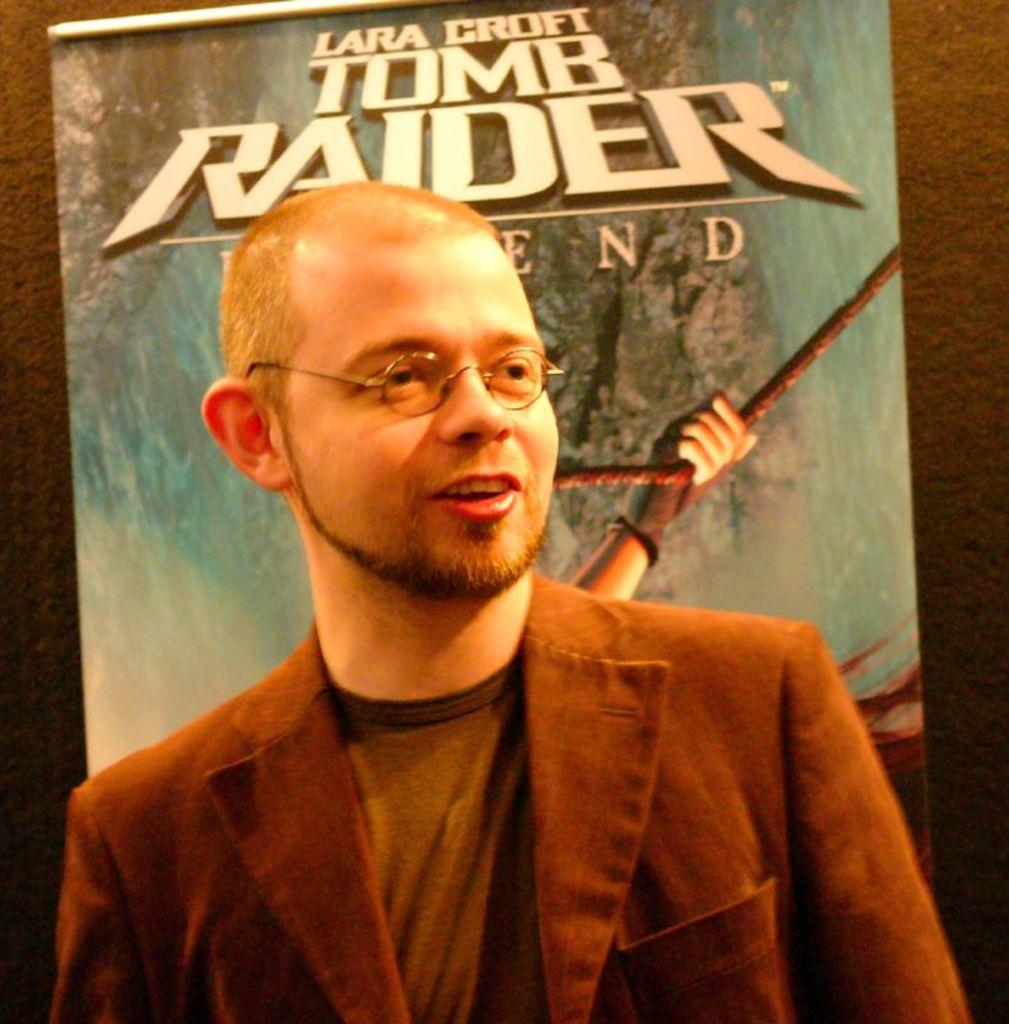What is the main subject of the image? There is a man standing in the image. Can you describe the man's appearance? The man is wearing spectacles. What can be seen in the background of the image? There is a banner on a wall in the background of the image. What is the tendency of the plastic print in the image? There is no plastic print present in the image. 